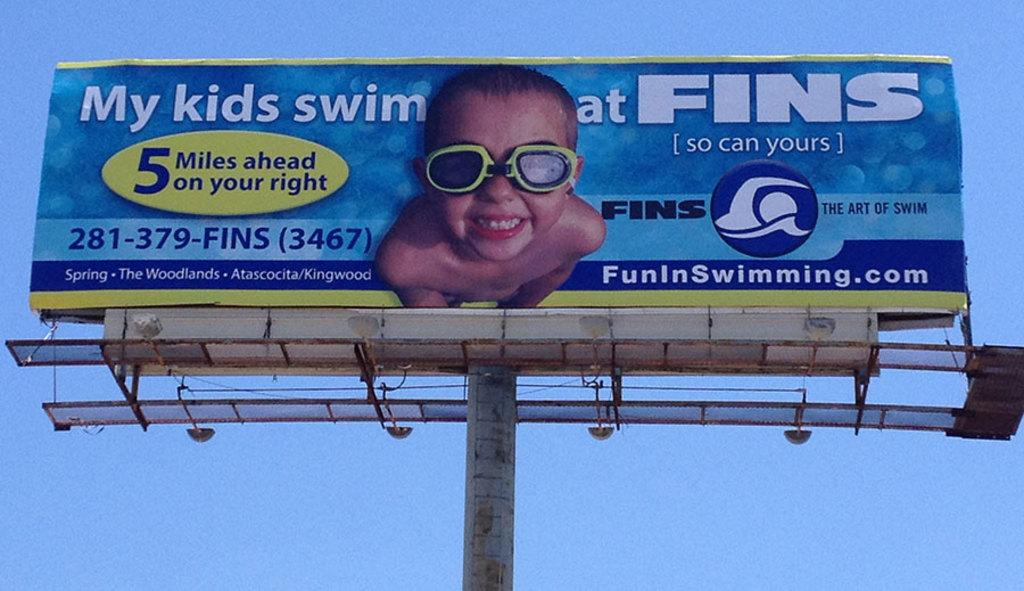<image>
Render a clear and concise summary of the photo. Blue billboard with a boy on it which says "My kids swim at FINS". 